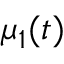<formula> <loc_0><loc_0><loc_500><loc_500>\mu _ { 1 } ( t )</formula> 